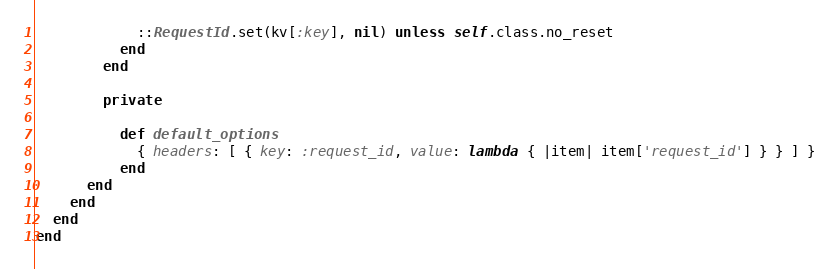Convert code to text. <code><loc_0><loc_0><loc_500><loc_500><_Ruby_>            ::RequestId.set(kv[:key], nil) unless self.class.no_reset
          end
        end

        private

          def default_options
            { headers: [ { key: :request_id, value: lambda { |item| item['request_id'] } } ] }
          end
      end
    end
  end
end
</code> 